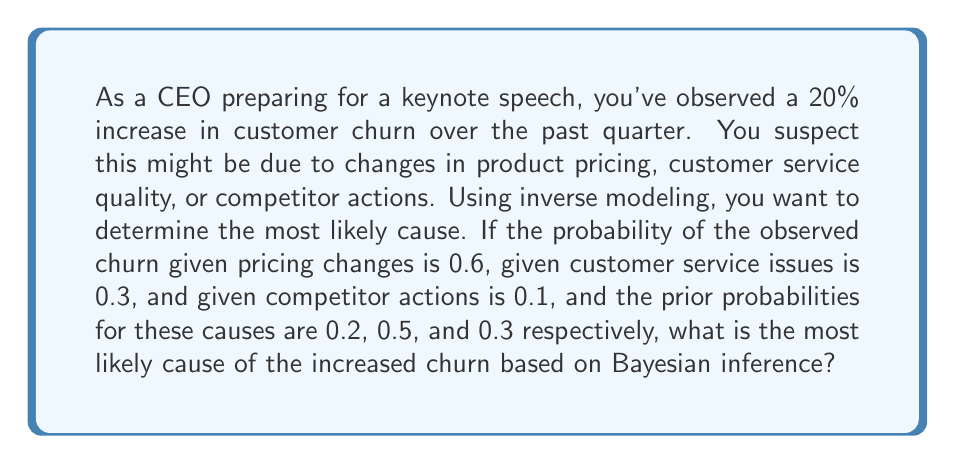Provide a solution to this math problem. To solve this problem, we'll use Bayes' theorem to calculate the posterior probability for each potential cause. The cause with the highest posterior probability will be the most likely cause of the increased churn.

Bayes' theorem is given by:

$$P(A|B) = \frac{P(B|A) \cdot P(A)}{P(B)}$$

Where:
$A$ is the cause we're investigating
$B$ is the observed effect (increased churn)
$P(A|B)$ is the posterior probability of the cause given the effect
$P(B|A)$ is the likelihood of the effect given the cause
$P(A)$ is the prior probability of the cause
$P(B)$ is the total probability of the effect

Let's calculate the posterior probability for each cause:

1. Pricing changes:
$P(B|A) = 0.6$
$P(A) = 0.2$

2. Customer service issues:
$P(B|A) = 0.3$
$P(A) = 0.5$

3. Competitor actions:
$P(B|A) = 0.1$
$P(A) = 0.3$

First, we need to calculate $P(B)$:
$$P(B) = (0.6 \cdot 0.2) + (0.3 \cdot 0.5) + (0.1 \cdot 0.3) = 0.12 + 0.15 + 0.03 = 0.3$$

Now, let's calculate the posterior probability for each cause:

1. Pricing changes:
$$P(A|B) = \frac{0.6 \cdot 0.2}{0.3} = 0.4$$

2. Customer service issues:
$$P(A|B) = \frac{0.3 \cdot 0.5}{0.3} = 0.5$$

3. Competitor actions:
$$P(A|B) = \frac{0.1 \cdot 0.3}{0.3} = 0.1$$

The highest posterior probability is 0.5, corresponding to customer service issues.
Answer: Customer service issues 